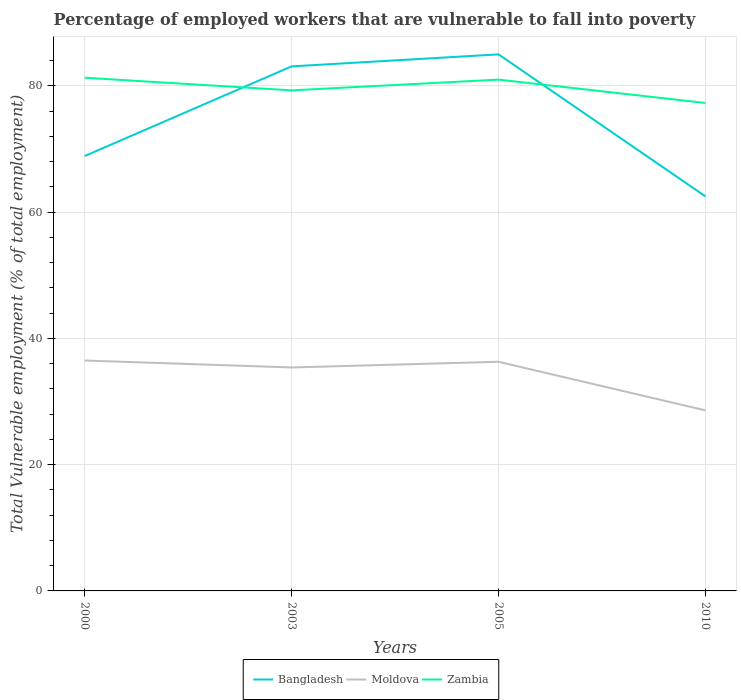How many different coloured lines are there?
Give a very brief answer. 3. Across all years, what is the maximum percentage of employed workers who are vulnerable to fall into poverty in Bangladesh?
Provide a short and direct response. 62.5. In which year was the percentage of employed workers who are vulnerable to fall into poverty in Moldova maximum?
Provide a short and direct response. 2010. What is the total percentage of employed workers who are vulnerable to fall into poverty in Moldova in the graph?
Your response must be concise. 0.2. What is the difference between the highest and the second highest percentage of employed workers who are vulnerable to fall into poverty in Moldova?
Make the answer very short. 7.9. What is the difference between the highest and the lowest percentage of employed workers who are vulnerable to fall into poverty in Zambia?
Your answer should be compact. 2. What is the difference between two consecutive major ticks on the Y-axis?
Offer a terse response. 20. Where does the legend appear in the graph?
Your answer should be very brief. Bottom center. How many legend labels are there?
Make the answer very short. 3. What is the title of the graph?
Offer a terse response. Percentage of employed workers that are vulnerable to fall into poverty. Does "Central African Republic" appear as one of the legend labels in the graph?
Ensure brevity in your answer.  No. What is the label or title of the Y-axis?
Provide a short and direct response. Total Vulnerable employment (% of total employment). What is the Total Vulnerable employment (% of total employment) of Bangladesh in 2000?
Ensure brevity in your answer.  68.9. What is the Total Vulnerable employment (% of total employment) of Moldova in 2000?
Give a very brief answer. 36.5. What is the Total Vulnerable employment (% of total employment) of Zambia in 2000?
Provide a short and direct response. 81.3. What is the Total Vulnerable employment (% of total employment) in Bangladesh in 2003?
Provide a short and direct response. 83.1. What is the Total Vulnerable employment (% of total employment) in Moldova in 2003?
Your answer should be compact. 35.4. What is the Total Vulnerable employment (% of total employment) of Zambia in 2003?
Provide a succinct answer. 79.3. What is the Total Vulnerable employment (% of total employment) in Moldova in 2005?
Ensure brevity in your answer.  36.3. What is the Total Vulnerable employment (% of total employment) of Zambia in 2005?
Make the answer very short. 81. What is the Total Vulnerable employment (% of total employment) of Bangladesh in 2010?
Provide a succinct answer. 62.5. What is the Total Vulnerable employment (% of total employment) in Moldova in 2010?
Offer a very short reply. 28.6. What is the Total Vulnerable employment (% of total employment) in Zambia in 2010?
Your response must be concise. 77.3. Across all years, what is the maximum Total Vulnerable employment (% of total employment) of Bangladesh?
Your response must be concise. 85. Across all years, what is the maximum Total Vulnerable employment (% of total employment) of Moldova?
Your answer should be compact. 36.5. Across all years, what is the maximum Total Vulnerable employment (% of total employment) of Zambia?
Provide a short and direct response. 81.3. Across all years, what is the minimum Total Vulnerable employment (% of total employment) of Bangladesh?
Give a very brief answer. 62.5. Across all years, what is the minimum Total Vulnerable employment (% of total employment) of Moldova?
Offer a terse response. 28.6. Across all years, what is the minimum Total Vulnerable employment (% of total employment) in Zambia?
Offer a terse response. 77.3. What is the total Total Vulnerable employment (% of total employment) in Bangladesh in the graph?
Keep it short and to the point. 299.5. What is the total Total Vulnerable employment (% of total employment) in Moldova in the graph?
Keep it short and to the point. 136.8. What is the total Total Vulnerable employment (% of total employment) of Zambia in the graph?
Offer a terse response. 318.9. What is the difference between the Total Vulnerable employment (% of total employment) in Bangladesh in 2000 and that in 2003?
Provide a succinct answer. -14.2. What is the difference between the Total Vulnerable employment (% of total employment) in Moldova in 2000 and that in 2003?
Your answer should be compact. 1.1. What is the difference between the Total Vulnerable employment (% of total employment) in Bangladesh in 2000 and that in 2005?
Offer a very short reply. -16.1. What is the difference between the Total Vulnerable employment (% of total employment) of Bangladesh in 2003 and that in 2010?
Give a very brief answer. 20.6. What is the difference between the Total Vulnerable employment (% of total employment) in Moldova in 2003 and that in 2010?
Your answer should be very brief. 6.8. What is the difference between the Total Vulnerable employment (% of total employment) of Moldova in 2005 and that in 2010?
Provide a succinct answer. 7.7. What is the difference between the Total Vulnerable employment (% of total employment) in Zambia in 2005 and that in 2010?
Provide a short and direct response. 3.7. What is the difference between the Total Vulnerable employment (% of total employment) in Bangladesh in 2000 and the Total Vulnerable employment (% of total employment) in Moldova in 2003?
Keep it short and to the point. 33.5. What is the difference between the Total Vulnerable employment (% of total employment) of Moldova in 2000 and the Total Vulnerable employment (% of total employment) of Zambia in 2003?
Provide a succinct answer. -42.8. What is the difference between the Total Vulnerable employment (% of total employment) in Bangladesh in 2000 and the Total Vulnerable employment (% of total employment) in Moldova in 2005?
Make the answer very short. 32.6. What is the difference between the Total Vulnerable employment (% of total employment) in Moldova in 2000 and the Total Vulnerable employment (% of total employment) in Zambia in 2005?
Keep it short and to the point. -44.5. What is the difference between the Total Vulnerable employment (% of total employment) of Bangladesh in 2000 and the Total Vulnerable employment (% of total employment) of Moldova in 2010?
Offer a very short reply. 40.3. What is the difference between the Total Vulnerable employment (% of total employment) of Bangladesh in 2000 and the Total Vulnerable employment (% of total employment) of Zambia in 2010?
Give a very brief answer. -8.4. What is the difference between the Total Vulnerable employment (% of total employment) in Moldova in 2000 and the Total Vulnerable employment (% of total employment) in Zambia in 2010?
Ensure brevity in your answer.  -40.8. What is the difference between the Total Vulnerable employment (% of total employment) in Bangladesh in 2003 and the Total Vulnerable employment (% of total employment) in Moldova in 2005?
Provide a succinct answer. 46.8. What is the difference between the Total Vulnerable employment (% of total employment) of Bangladesh in 2003 and the Total Vulnerable employment (% of total employment) of Zambia in 2005?
Your answer should be compact. 2.1. What is the difference between the Total Vulnerable employment (% of total employment) in Moldova in 2003 and the Total Vulnerable employment (% of total employment) in Zambia in 2005?
Keep it short and to the point. -45.6. What is the difference between the Total Vulnerable employment (% of total employment) of Bangladesh in 2003 and the Total Vulnerable employment (% of total employment) of Moldova in 2010?
Provide a succinct answer. 54.5. What is the difference between the Total Vulnerable employment (% of total employment) in Bangladesh in 2003 and the Total Vulnerable employment (% of total employment) in Zambia in 2010?
Offer a terse response. 5.8. What is the difference between the Total Vulnerable employment (% of total employment) in Moldova in 2003 and the Total Vulnerable employment (% of total employment) in Zambia in 2010?
Offer a terse response. -41.9. What is the difference between the Total Vulnerable employment (% of total employment) in Bangladesh in 2005 and the Total Vulnerable employment (% of total employment) in Moldova in 2010?
Give a very brief answer. 56.4. What is the difference between the Total Vulnerable employment (% of total employment) of Moldova in 2005 and the Total Vulnerable employment (% of total employment) of Zambia in 2010?
Your response must be concise. -41. What is the average Total Vulnerable employment (% of total employment) in Bangladesh per year?
Offer a terse response. 74.88. What is the average Total Vulnerable employment (% of total employment) in Moldova per year?
Keep it short and to the point. 34.2. What is the average Total Vulnerable employment (% of total employment) in Zambia per year?
Make the answer very short. 79.72. In the year 2000, what is the difference between the Total Vulnerable employment (% of total employment) in Bangladesh and Total Vulnerable employment (% of total employment) in Moldova?
Ensure brevity in your answer.  32.4. In the year 2000, what is the difference between the Total Vulnerable employment (% of total employment) of Moldova and Total Vulnerable employment (% of total employment) of Zambia?
Your answer should be compact. -44.8. In the year 2003, what is the difference between the Total Vulnerable employment (% of total employment) in Bangladesh and Total Vulnerable employment (% of total employment) in Moldova?
Provide a succinct answer. 47.7. In the year 2003, what is the difference between the Total Vulnerable employment (% of total employment) of Moldova and Total Vulnerable employment (% of total employment) of Zambia?
Your answer should be very brief. -43.9. In the year 2005, what is the difference between the Total Vulnerable employment (% of total employment) of Bangladesh and Total Vulnerable employment (% of total employment) of Moldova?
Your answer should be very brief. 48.7. In the year 2005, what is the difference between the Total Vulnerable employment (% of total employment) in Bangladesh and Total Vulnerable employment (% of total employment) in Zambia?
Keep it short and to the point. 4. In the year 2005, what is the difference between the Total Vulnerable employment (% of total employment) in Moldova and Total Vulnerable employment (% of total employment) in Zambia?
Provide a succinct answer. -44.7. In the year 2010, what is the difference between the Total Vulnerable employment (% of total employment) in Bangladesh and Total Vulnerable employment (% of total employment) in Moldova?
Keep it short and to the point. 33.9. In the year 2010, what is the difference between the Total Vulnerable employment (% of total employment) in Bangladesh and Total Vulnerable employment (% of total employment) in Zambia?
Offer a terse response. -14.8. In the year 2010, what is the difference between the Total Vulnerable employment (% of total employment) in Moldova and Total Vulnerable employment (% of total employment) in Zambia?
Your response must be concise. -48.7. What is the ratio of the Total Vulnerable employment (% of total employment) of Bangladesh in 2000 to that in 2003?
Offer a very short reply. 0.83. What is the ratio of the Total Vulnerable employment (% of total employment) of Moldova in 2000 to that in 2003?
Give a very brief answer. 1.03. What is the ratio of the Total Vulnerable employment (% of total employment) in Zambia in 2000 to that in 2003?
Offer a very short reply. 1.03. What is the ratio of the Total Vulnerable employment (% of total employment) of Bangladesh in 2000 to that in 2005?
Keep it short and to the point. 0.81. What is the ratio of the Total Vulnerable employment (% of total employment) in Moldova in 2000 to that in 2005?
Offer a very short reply. 1.01. What is the ratio of the Total Vulnerable employment (% of total employment) in Bangladesh in 2000 to that in 2010?
Offer a very short reply. 1.1. What is the ratio of the Total Vulnerable employment (% of total employment) of Moldova in 2000 to that in 2010?
Provide a short and direct response. 1.28. What is the ratio of the Total Vulnerable employment (% of total employment) in Zambia in 2000 to that in 2010?
Keep it short and to the point. 1.05. What is the ratio of the Total Vulnerable employment (% of total employment) of Bangladesh in 2003 to that in 2005?
Your response must be concise. 0.98. What is the ratio of the Total Vulnerable employment (% of total employment) of Moldova in 2003 to that in 2005?
Provide a short and direct response. 0.98. What is the ratio of the Total Vulnerable employment (% of total employment) in Bangladesh in 2003 to that in 2010?
Offer a terse response. 1.33. What is the ratio of the Total Vulnerable employment (% of total employment) in Moldova in 2003 to that in 2010?
Provide a short and direct response. 1.24. What is the ratio of the Total Vulnerable employment (% of total employment) in Zambia in 2003 to that in 2010?
Provide a succinct answer. 1.03. What is the ratio of the Total Vulnerable employment (% of total employment) in Bangladesh in 2005 to that in 2010?
Keep it short and to the point. 1.36. What is the ratio of the Total Vulnerable employment (% of total employment) in Moldova in 2005 to that in 2010?
Offer a very short reply. 1.27. What is the ratio of the Total Vulnerable employment (% of total employment) in Zambia in 2005 to that in 2010?
Ensure brevity in your answer.  1.05. What is the difference between the highest and the second highest Total Vulnerable employment (% of total employment) of Zambia?
Ensure brevity in your answer.  0.3. 